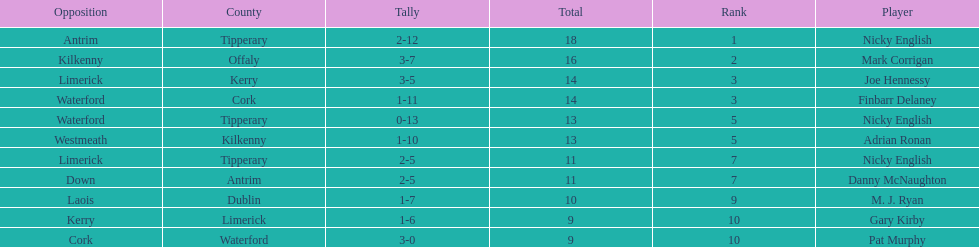How many people are on the list? 9. Parse the full table. {'header': ['Opposition', 'County', 'Tally', 'Total', 'Rank', 'Player'], 'rows': [['Antrim', 'Tipperary', '2-12', '18', '1', 'Nicky English'], ['Kilkenny', 'Offaly', '3-7', '16', '2', 'Mark Corrigan'], ['Limerick', 'Kerry', '3-5', '14', '3', 'Joe Hennessy'], ['Waterford', 'Cork', '1-11', '14', '3', 'Finbarr Delaney'], ['Waterford', 'Tipperary', '0-13', '13', '5', 'Nicky English'], ['Westmeath', 'Kilkenny', '1-10', '13', '5', 'Adrian Ronan'], ['Limerick', 'Tipperary', '2-5', '11', '7', 'Nicky English'], ['Down', 'Antrim', '2-5', '11', '7', 'Danny McNaughton'], ['Laois', 'Dublin', '1-7', '10', '9', 'M. J. Ryan'], ['Kerry', 'Limerick', '1-6', '9', '10', 'Gary Kirby'], ['Cork', 'Waterford', '3-0', '9', '10', 'Pat Murphy']]} 